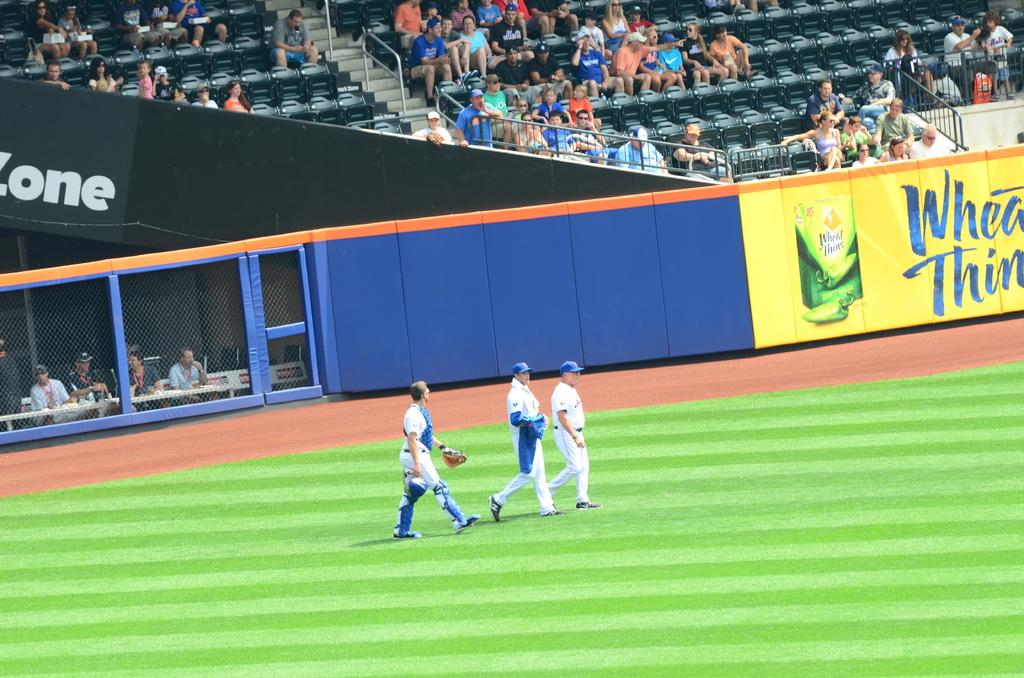Provide a one-sentence caption for the provided image. A Wheat Thins advertisement covers a section of the wall of a baseball stadium. 